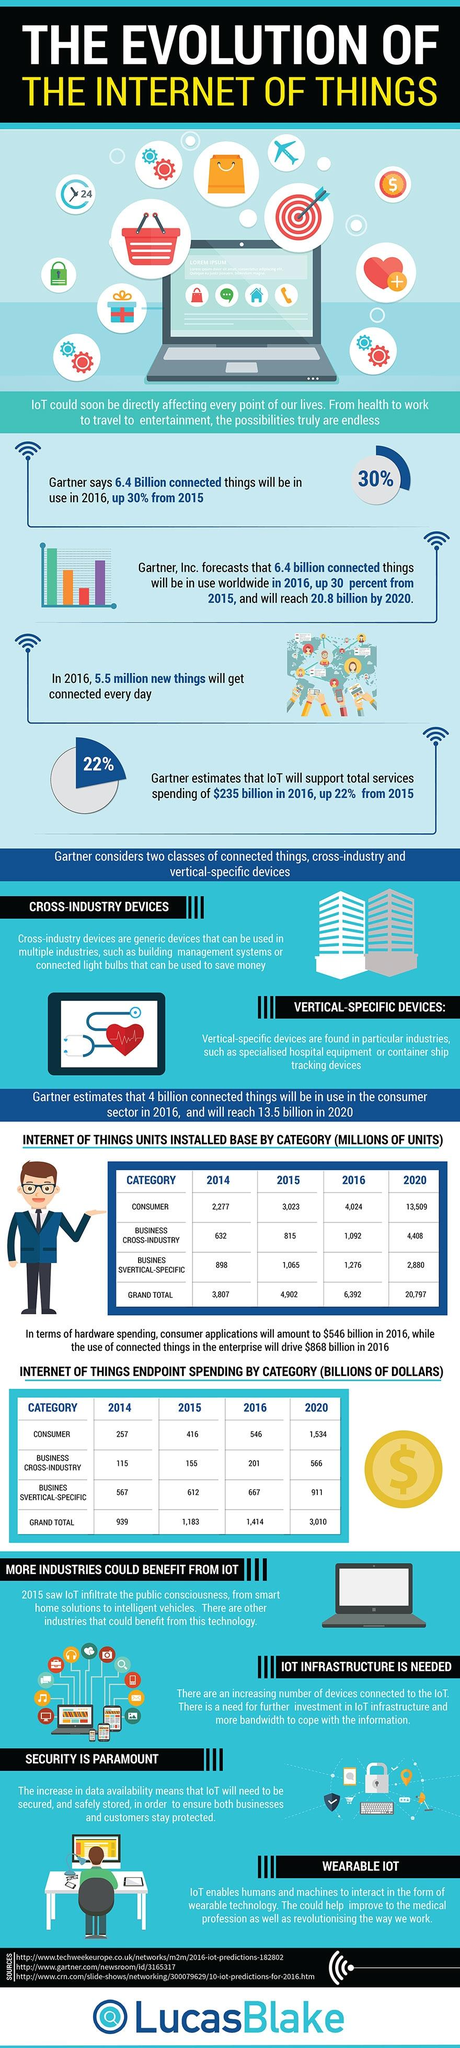Specify some key components in this picture. The infographic mentions two types of devices: cross-industry devices and vertical-specific devices. 